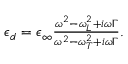Convert formula to latex. <formula><loc_0><loc_0><loc_500><loc_500>\begin{array} { r } { \epsilon _ { d } = \epsilon _ { \infty } \frac { \omega ^ { 2 } - \omega _ { L } ^ { 2 } + i \omega \Gamma } { \omega ^ { 2 } - \omega _ { T } ^ { 2 } + i \omega \Gamma } . } \end{array}</formula> 